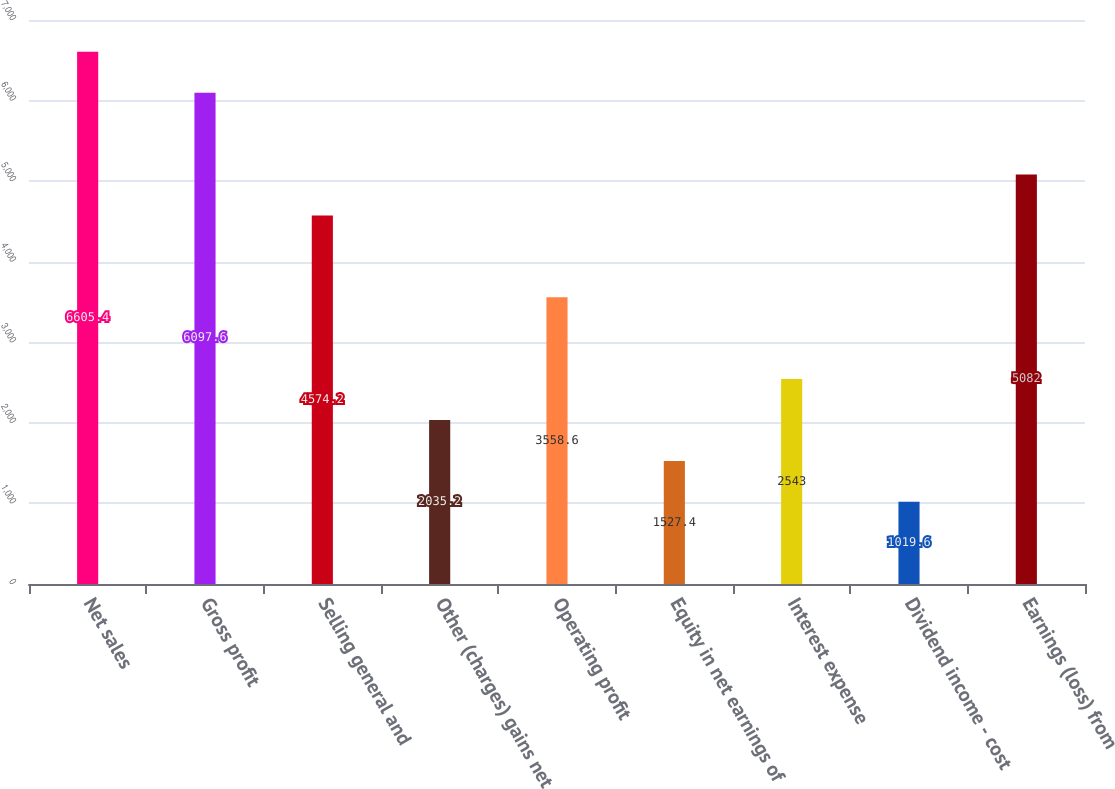<chart> <loc_0><loc_0><loc_500><loc_500><bar_chart><fcel>Net sales<fcel>Gross profit<fcel>Selling general and<fcel>Other (charges) gains net<fcel>Operating profit<fcel>Equity in net earnings of<fcel>Interest expense<fcel>Dividend income - cost<fcel>Earnings (loss) from<nl><fcel>6605.4<fcel>6097.6<fcel>4574.2<fcel>2035.2<fcel>3558.6<fcel>1527.4<fcel>2543<fcel>1019.6<fcel>5082<nl></chart> 